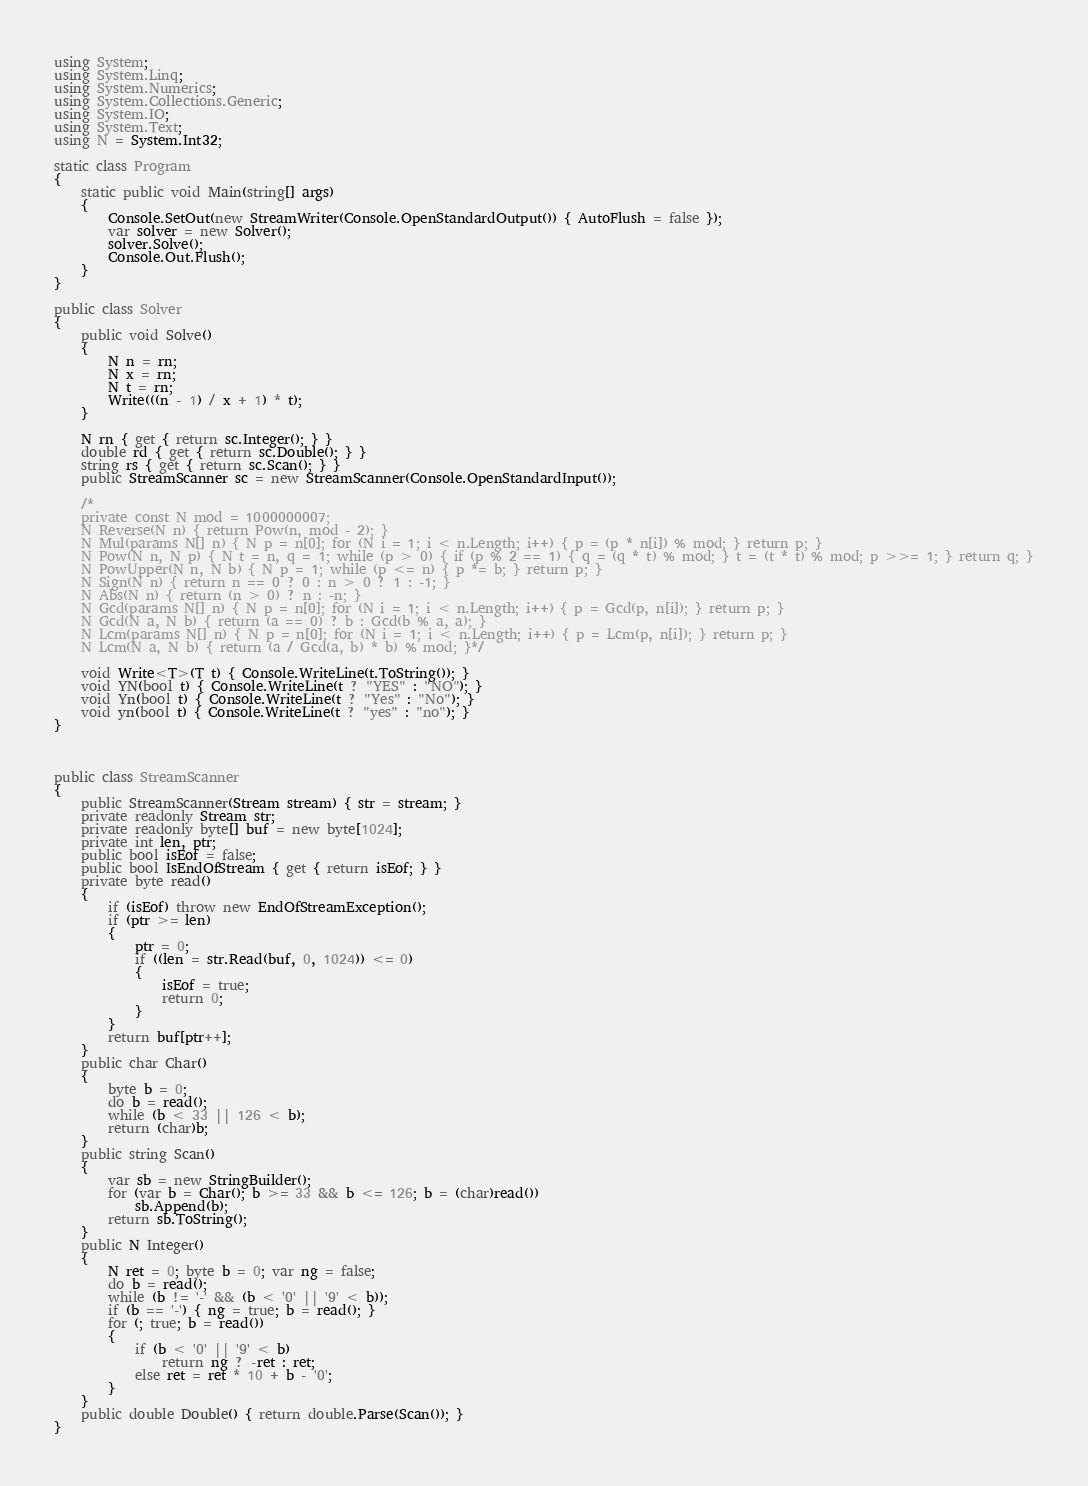Convert code to text. <code><loc_0><loc_0><loc_500><loc_500><_C#_>using System;
using System.Linq;
using System.Numerics;
using System.Collections.Generic;
using System.IO;
using System.Text;
using N = System.Int32;

static class Program
{
    static public void Main(string[] args)
    {
        Console.SetOut(new StreamWriter(Console.OpenStandardOutput()) { AutoFlush = false });
        var solver = new Solver();
        solver.Solve();
        Console.Out.Flush();
    }
}

public class Solver
{
    public void Solve()
    {
        N n = rn;
        N x = rn;
        N t = rn;
        Write(((n - 1) / x + 1) * t);
    }

    N rn { get { return sc.Integer(); } }
    double rd { get { return sc.Double(); } }
    string rs { get { return sc.Scan(); } }
    public StreamScanner sc = new StreamScanner(Console.OpenStandardInput());

    /*
    private const N mod = 1000000007;
    N Reverse(N n) { return Pow(n, mod - 2); }
    N Mul(params N[] n) { N p = n[0]; for (N i = 1; i < n.Length; i++) { p = (p * n[i]) % mod; } return p; }
    N Pow(N n, N p) { N t = n, q = 1; while (p > 0) { if (p % 2 == 1) { q = (q * t) % mod; } t = (t * t) % mod; p >>= 1; } return q; }
    N PowUpper(N n, N b) { N p = 1; while (p <= n) { p *= b; } return p; }
    N Sign(N n) { return n == 0 ? 0 : n > 0 ? 1 : -1; }
    N Abs(N n) { return (n > 0) ? n : -n; }
    N Gcd(params N[] n) { N p = n[0]; for (N i = 1; i < n.Length; i++) { p = Gcd(p, n[i]); } return p; }
    N Gcd(N a, N b) { return (a == 0) ? b : Gcd(b % a, a); }
    N Lcm(params N[] n) { N p = n[0]; for (N i = 1; i < n.Length; i++) { p = Lcm(p, n[i]); } return p; }
    N Lcm(N a, N b) { return (a / Gcd(a, b) * b) % mod; }*/

    void Write<T>(T t) { Console.WriteLine(t.ToString()); }
    void YN(bool t) { Console.WriteLine(t ? "YES" : "NO"); }
    void Yn(bool t) { Console.WriteLine(t ? "Yes" : "No"); }
    void yn(bool t) { Console.WriteLine(t ? "yes" : "no"); }
}



public class StreamScanner
{
    public StreamScanner(Stream stream) { str = stream; }
    private readonly Stream str;
    private readonly byte[] buf = new byte[1024];
    private int len, ptr;
    public bool isEof = false;
    public bool IsEndOfStream { get { return isEof; } }
    private byte read()
    {
        if (isEof) throw new EndOfStreamException();
        if (ptr >= len)
        {
            ptr = 0;
            if ((len = str.Read(buf, 0, 1024)) <= 0)
            {
                isEof = true;
                return 0;
            }
        }
        return buf[ptr++];
    }
    public char Char()
    {
        byte b = 0;
        do b = read();
        while (b < 33 || 126 < b);
        return (char)b;
    }
    public string Scan()
    {
        var sb = new StringBuilder();
        for (var b = Char(); b >= 33 && b <= 126; b = (char)read())
            sb.Append(b);
        return sb.ToString();
    }
    public N Integer()
    {
        N ret = 0; byte b = 0; var ng = false;
        do b = read();
        while (b != '-' && (b < '0' || '9' < b));
        if (b == '-') { ng = true; b = read(); }
        for (; true; b = read())
        {
            if (b < '0' || '9' < b)
                return ng ? -ret : ret;
            else ret = ret * 10 + b - '0';
        }
    }
    public double Double() { return double.Parse(Scan()); }
}
</code> 